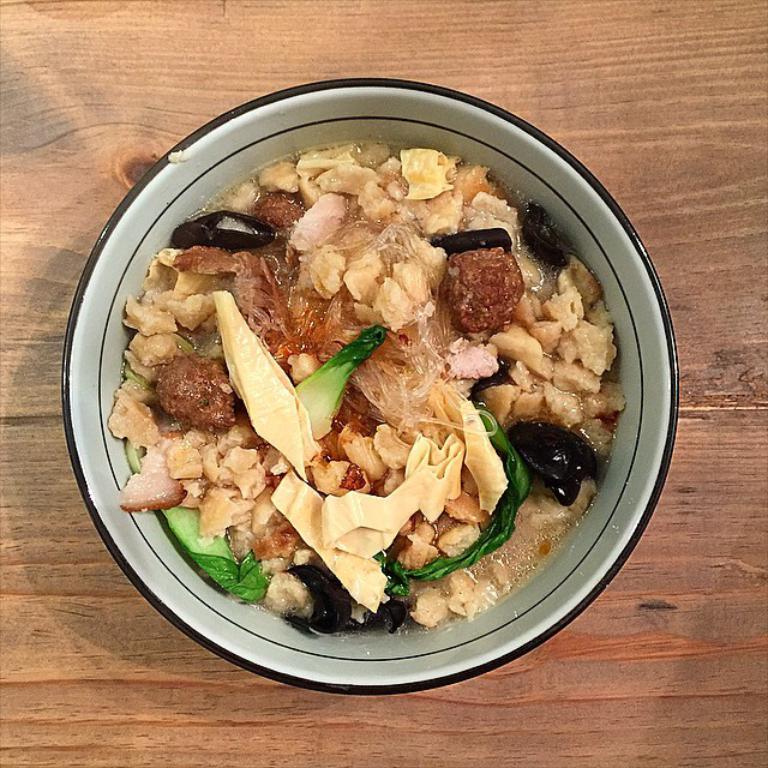Can you describe this image briefly? In this picture I can see food item in the bowl on the wooden floor. 